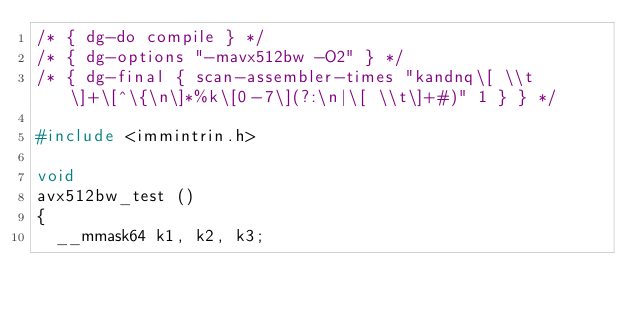Convert code to text. <code><loc_0><loc_0><loc_500><loc_500><_C_>/* { dg-do compile } */
/* { dg-options "-mavx512bw -O2" } */
/* { dg-final { scan-assembler-times "kandnq\[ \\t\]+\[^\{\n\]*%k\[0-7\](?:\n|\[ \\t\]+#)" 1 } } */

#include <immintrin.h>

void
avx512bw_test ()
{
  __mmask64 k1, k2, k3;</code> 